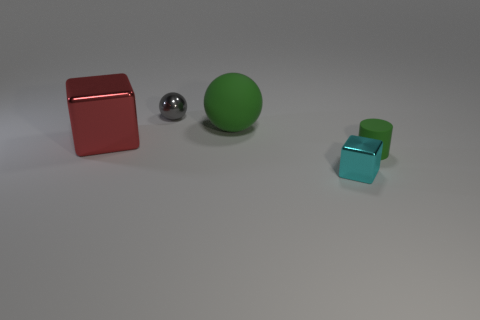How many balls are either tiny purple metal things or small green rubber things? In the image, there is one small green rubber ball among the objects presented. There are no tiny purple metal balls visible. The other objects include a larger red metal cube, a smaller shiny metal sphere, and two smaller blue transparent cubes. Therefore, there is a total of one ball that fits the criteria of being a small green rubber object. 